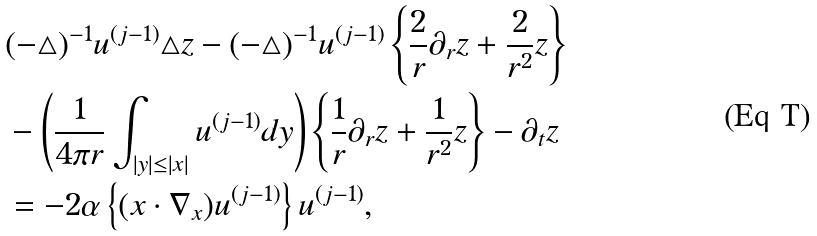Convert formula to latex. <formula><loc_0><loc_0><loc_500><loc_500>& ( - \triangle ) ^ { - 1 } u ^ { ( j - 1 ) } \triangle z - ( - \triangle ) ^ { - 1 } u ^ { ( j - 1 ) } \left \{ \frac { 2 } { r } \partial _ { r } z + \frac { 2 } { r ^ { 2 } } z \right \} \\ & - \left ( \frac { 1 } { 4 \pi r } \int _ { | y | \leq | x | } u ^ { ( j - 1 ) } d y \right ) \left \{ \frac { 1 } { r } \partial _ { r } z + \frac { 1 } { r ^ { 2 } } z \right \} - \partial _ { t } z \\ & = - 2 \alpha \left \{ ( x \cdot \nabla _ { x } ) u ^ { ( j - 1 ) } \right \} u ^ { ( j - 1 ) } ,</formula> 